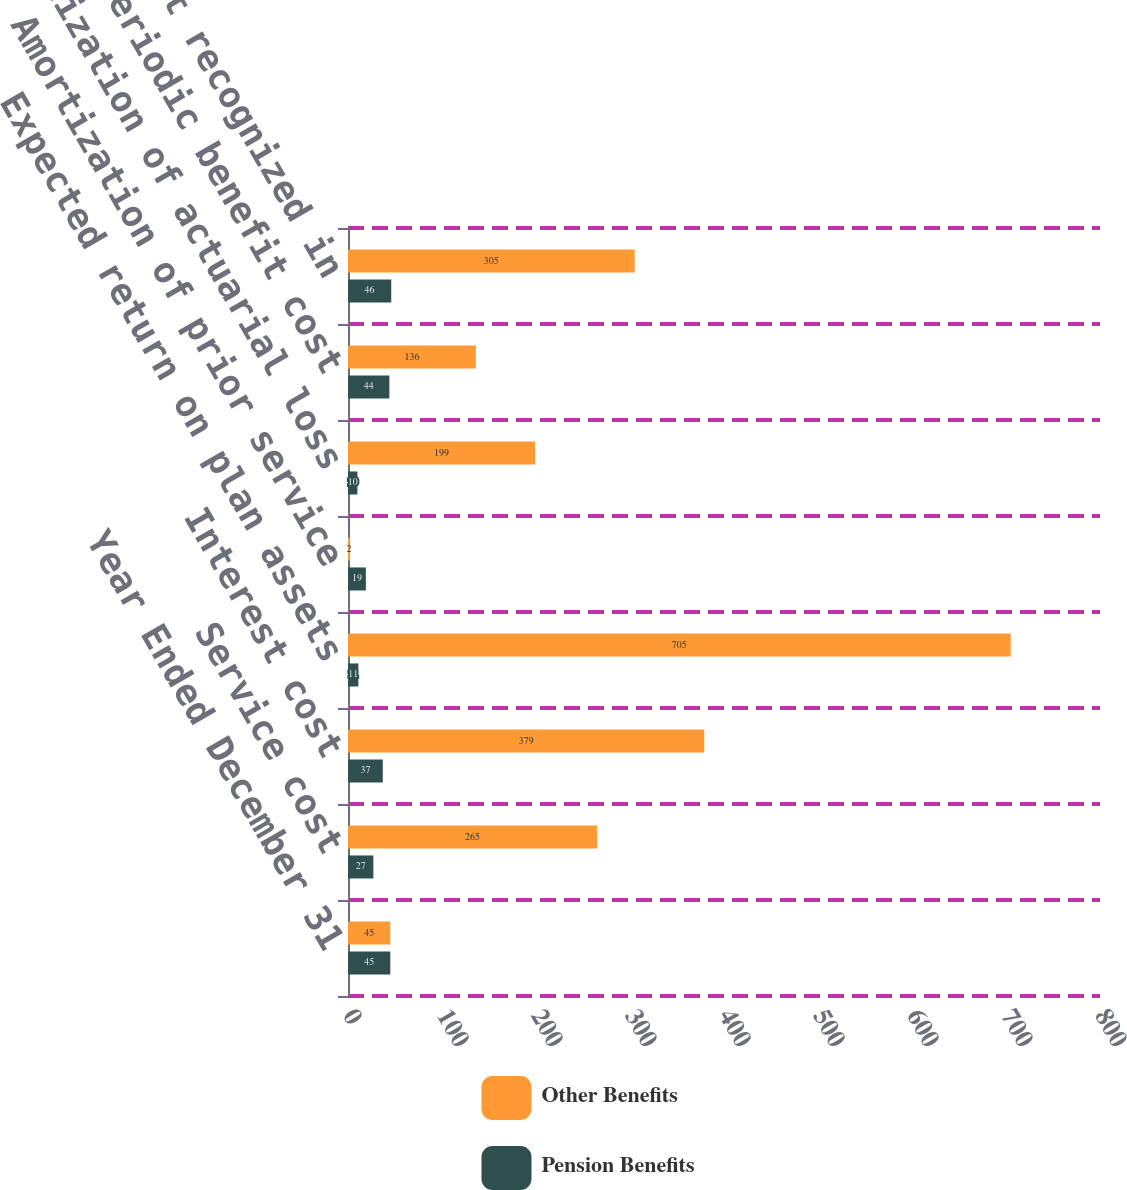Convert chart to OTSL. <chart><loc_0><loc_0><loc_500><loc_500><stacked_bar_chart><ecel><fcel>Year Ended December 31<fcel>Service cost<fcel>Interest cost<fcel>Expected return on plan assets<fcel>Amortization of prior service<fcel>Amortization of actuarial loss<fcel>Net periodic benefit cost<fcel>Total cost recognized in<nl><fcel>Other Benefits<fcel>45<fcel>265<fcel>379<fcel>705<fcel>2<fcel>199<fcel>136<fcel>305<nl><fcel>Pension Benefits<fcel>45<fcel>27<fcel>37<fcel>11<fcel>19<fcel>10<fcel>44<fcel>46<nl></chart> 